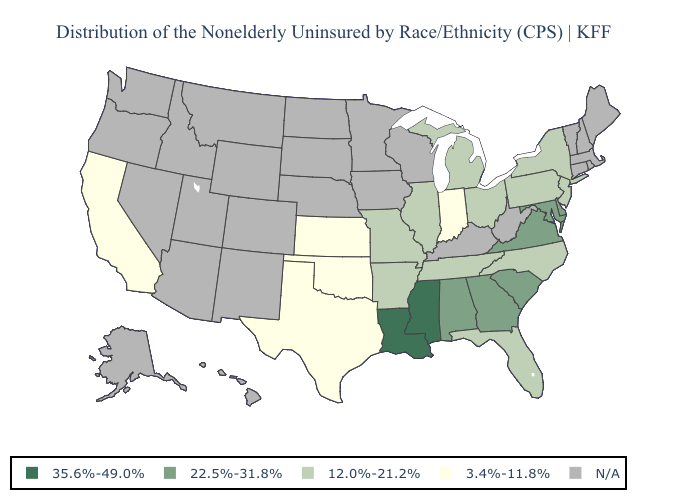Name the states that have a value in the range 35.6%-49.0%?
Write a very short answer. Louisiana, Mississippi. Name the states that have a value in the range 22.5%-31.8%?
Quick response, please. Alabama, Delaware, Georgia, Maryland, South Carolina, Virginia. Does Louisiana have the highest value in the USA?
Write a very short answer. Yes. What is the highest value in the MidWest ?
Be succinct. 12.0%-21.2%. Does New Jersey have the lowest value in the USA?
Be succinct. No. Does New Jersey have the lowest value in the USA?
Answer briefly. No. What is the value of Wisconsin?
Quick response, please. N/A. Does Louisiana have the lowest value in the USA?
Give a very brief answer. No. Does the map have missing data?
Answer briefly. Yes. What is the value of Georgia?
Be succinct. 22.5%-31.8%. What is the value of Tennessee?
Give a very brief answer. 12.0%-21.2%. Which states hav the highest value in the MidWest?
Quick response, please. Illinois, Michigan, Missouri, Ohio. What is the highest value in the USA?
Keep it brief. 35.6%-49.0%. Does the first symbol in the legend represent the smallest category?
Keep it brief. No. 